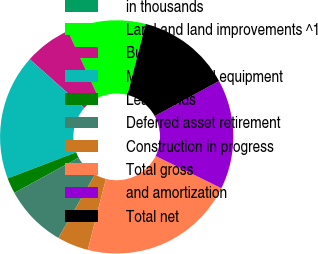Convert chart to OTSL. <chart><loc_0><loc_0><loc_500><loc_500><pie_chart><fcel>in thousands<fcel>Land and land improvements ^1<fcel>Buildings<fcel>Machinery and equipment<fcel>Leaseholds<fcel>Deferred asset retirement<fcel>Construction in progress<fcel>Total gross<fcel>and amortization<fcel>Total net<nl><fcel>0.01%<fcel>10.87%<fcel>6.52%<fcel>17.39%<fcel>2.18%<fcel>8.7%<fcel>4.35%<fcel>21.73%<fcel>15.21%<fcel>13.04%<nl></chart> 